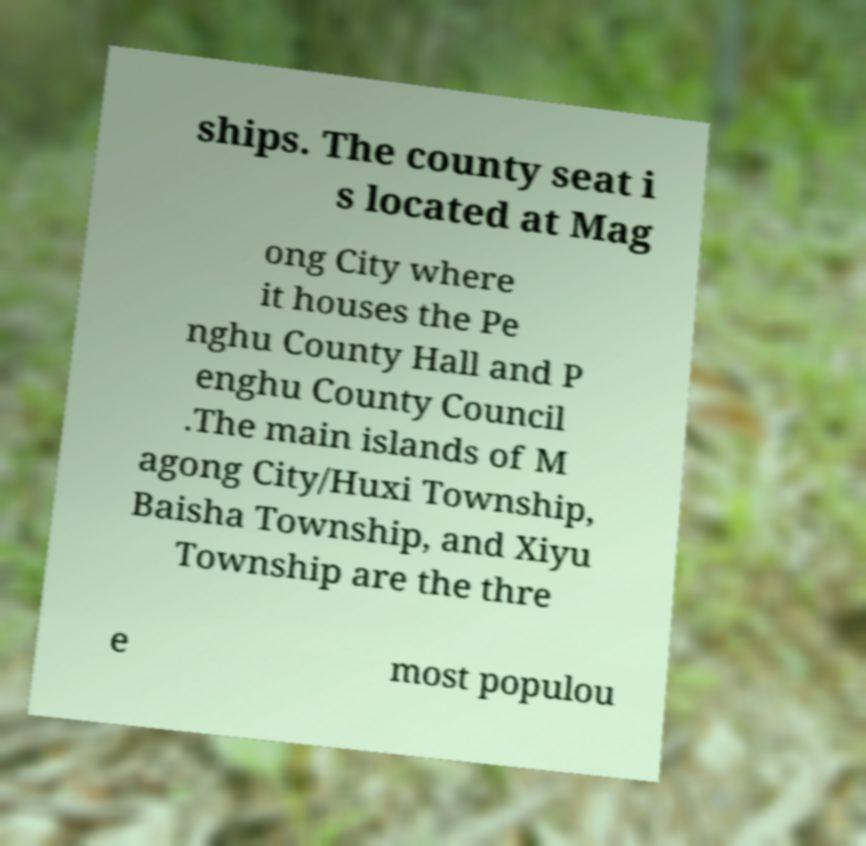Please read and relay the text visible in this image. What does it say? ships. The county seat i s located at Mag ong City where it houses the Pe nghu County Hall and P enghu County Council .The main islands of M agong City/Huxi Township, Baisha Township, and Xiyu Township are the thre e most populou 